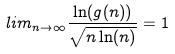Convert formula to latex. <formula><loc_0><loc_0><loc_500><loc_500>l i m _ { n \rightarrow \infty } \frac { \ln ( g ( n ) ) } { \sqrt { n \ln ( n ) } } = 1</formula> 